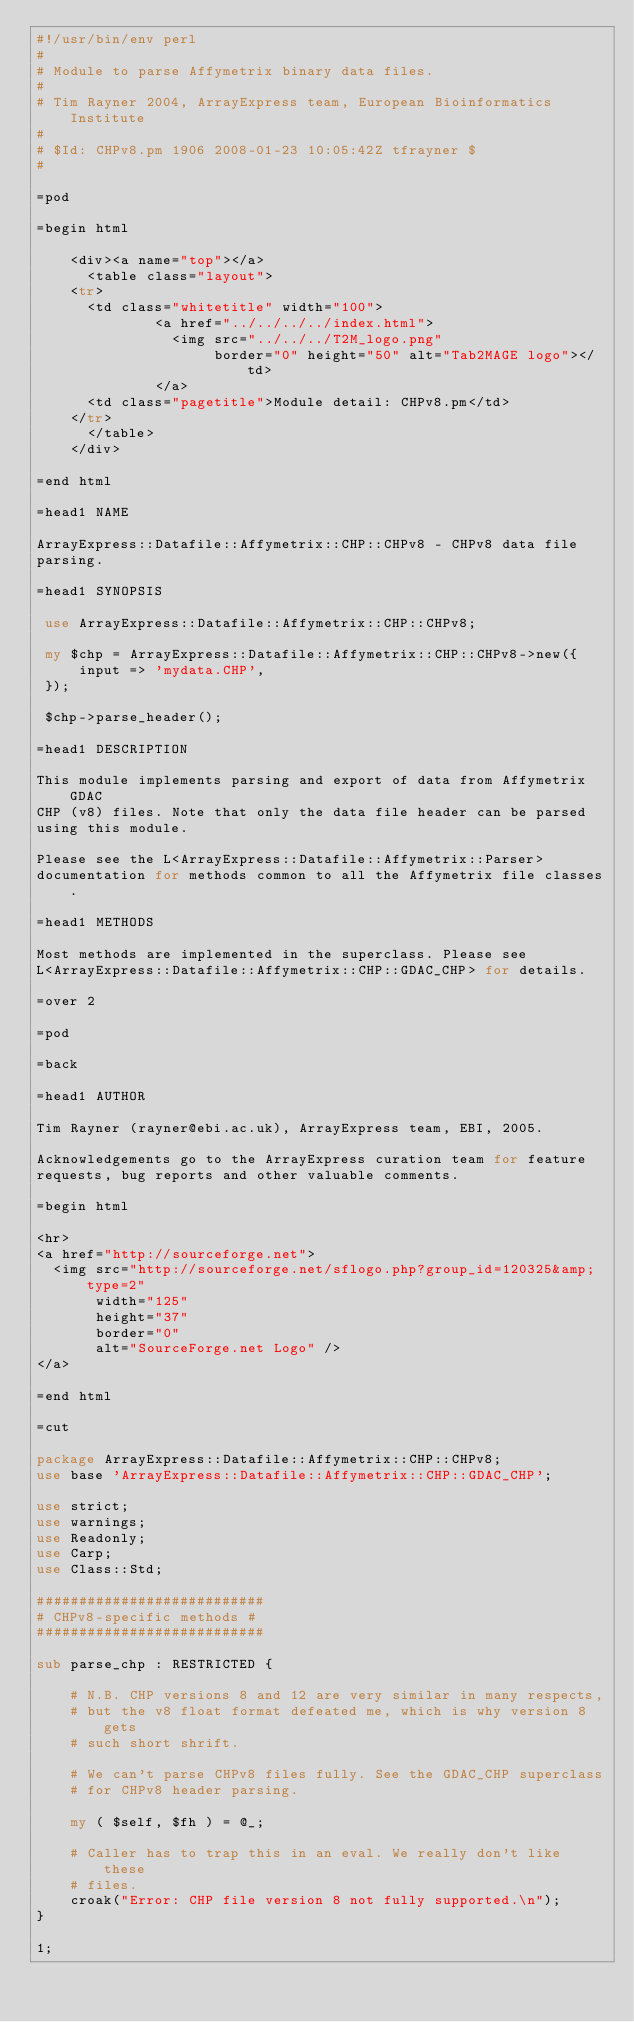<code> <loc_0><loc_0><loc_500><loc_500><_Perl_>#!/usr/bin/env perl
#
# Module to parse Affymetrix binary data files.
#
# Tim Rayner 2004, ArrayExpress team, European Bioinformatics Institute
#
# $Id: CHPv8.pm 1906 2008-01-23 10:05:42Z tfrayner $
#

=pod

=begin html

    <div><a name="top"></a>
      <table class="layout">
	  <tr>
	    <td class="whitetitle" width="100">
              <a href="../../../../index.html">
                <img src="../../../T2M_logo.png"
                     border="0" height="50" alt="Tab2MAGE logo"></td>
              </a>
	    <td class="pagetitle">Module detail: CHPv8.pm</td>
	  </tr>
      </table>
    </div>

=end html

=head1 NAME

ArrayExpress::Datafile::Affymetrix::CHP::CHPv8 - CHPv8 data file
parsing.

=head1 SYNOPSIS

 use ArrayExpress::Datafile::Affymetrix::CHP::CHPv8;

 my $chp = ArrayExpress::Datafile::Affymetrix::CHP::CHPv8->new({
     input => 'mydata.CHP',
 });

 $chp->parse_header();

=head1 DESCRIPTION

This module implements parsing and export of data from Affymetrix GDAC
CHP (v8) files. Note that only the data file header can be parsed
using this module.

Please see the L<ArrayExpress::Datafile::Affymetrix::Parser>
documentation for methods common to all the Affymetrix file classes.

=head1 METHODS

Most methods are implemented in the superclass. Please see
L<ArrayExpress::Datafile::Affymetrix::CHP::GDAC_CHP> for details.

=over 2

=pod

=back

=head1 AUTHOR

Tim Rayner (rayner@ebi.ac.uk), ArrayExpress team, EBI, 2005.

Acknowledgements go to the ArrayExpress curation team for feature
requests, bug reports and other valuable comments.

=begin html

<hr>
<a href="http://sourceforge.net">
  <img src="http://sourceforge.net/sflogo.php?group_id=120325&amp;type=2" 
       width="125" 
       height="37" 
       border="0" 
       alt="SourceForge.net Logo" />
</a>

=end html

=cut

package ArrayExpress::Datafile::Affymetrix::CHP::CHPv8;
use base 'ArrayExpress::Datafile::Affymetrix::CHP::GDAC_CHP';

use strict;
use warnings;
use Readonly;
use Carp;
use Class::Std;

###########################
# CHPv8-specific methods #
###########################

sub parse_chp : RESTRICTED {

    # N.B. CHP versions 8 and 12 are very similar in many respects,
    # but the v8 float format defeated me, which is why version 8 gets
    # such short shrift.

    # We can't parse CHPv8 files fully. See the GDAC_CHP superclass
    # for CHPv8 header parsing.

    my ( $self, $fh ) = @_;

    # Caller has to trap this in an eval. We really don't like these
    # files.
    croak("Error: CHP file version 8 not fully supported.\n");
}

1;
</code> 